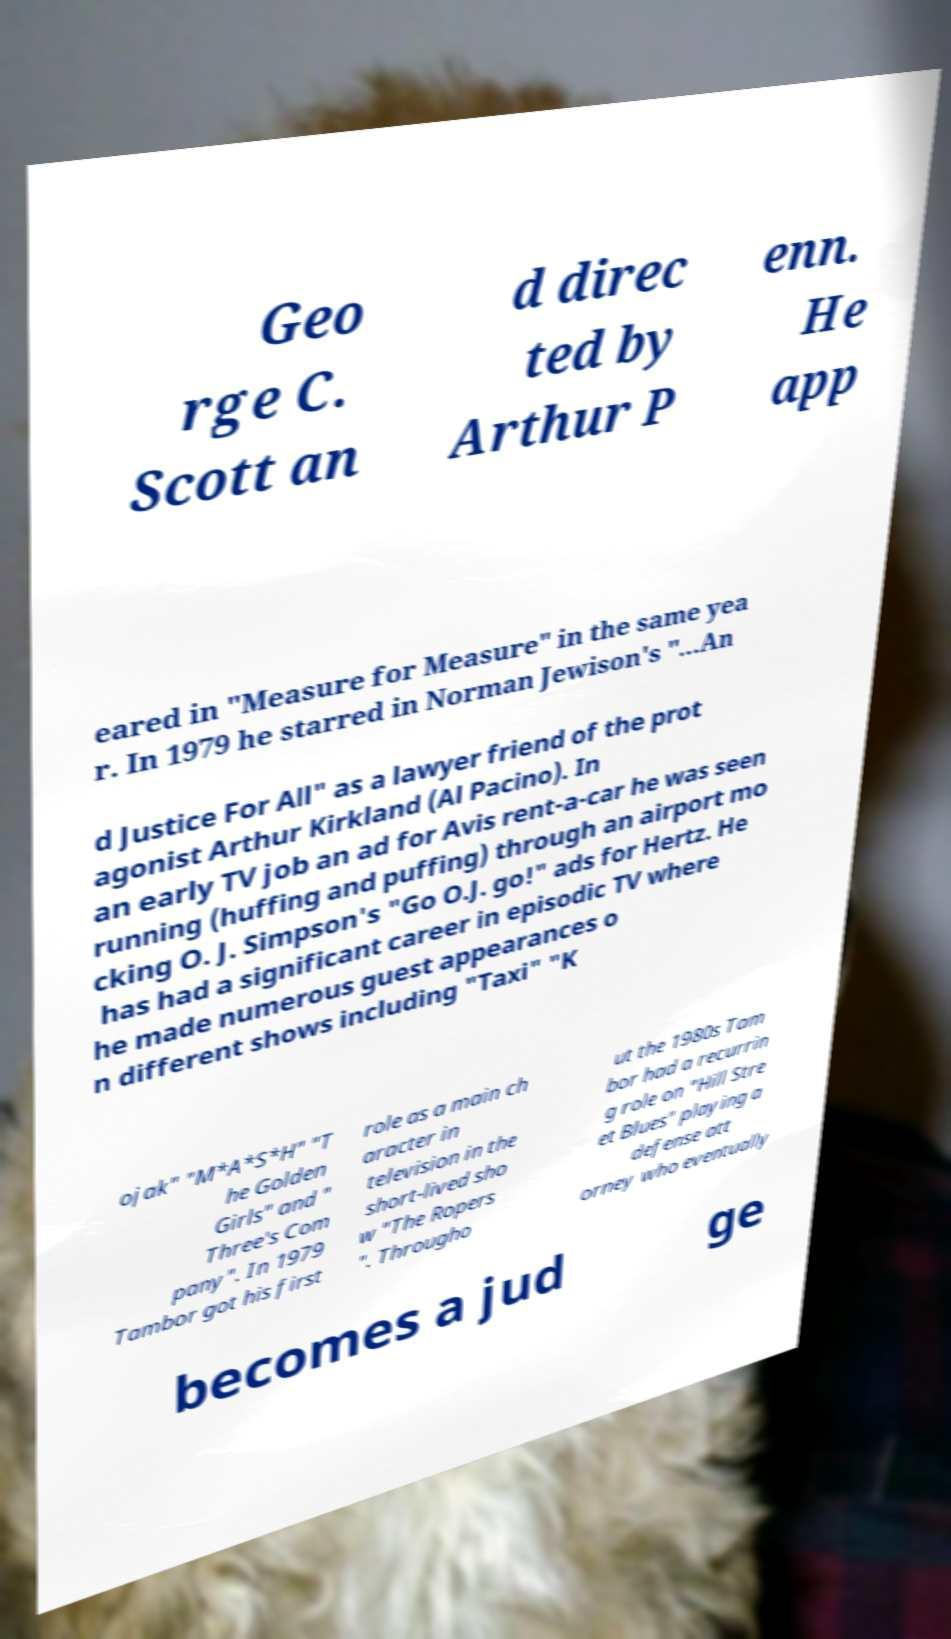Please read and relay the text visible in this image. What does it say? Geo rge C. Scott an d direc ted by Arthur P enn. He app eared in "Measure for Measure" in the same yea r. In 1979 he starred in Norman Jewison's "...An d Justice For All" as a lawyer friend of the prot agonist Arthur Kirkland (Al Pacino). In an early TV job an ad for Avis rent-a-car he was seen running (huffing and puffing) through an airport mo cking O. J. Simpson's "Go O.J. go!" ads for Hertz. He has had a significant career in episodic TV where he made numerous guest appearances o n different shows including "Taxi" "K ojak" "M*A*S*H" "T he Golden Girls" and " Three's Com pany". In 1979 Tambor got his first role as a main ch aracter in television in the short-lived sho w "The Ropers ". Througho ut the 1980s Tam bor had a recurrin g role on "Hill Stre et Blues" playing a defense att orney who eventually becomes a jud ge 